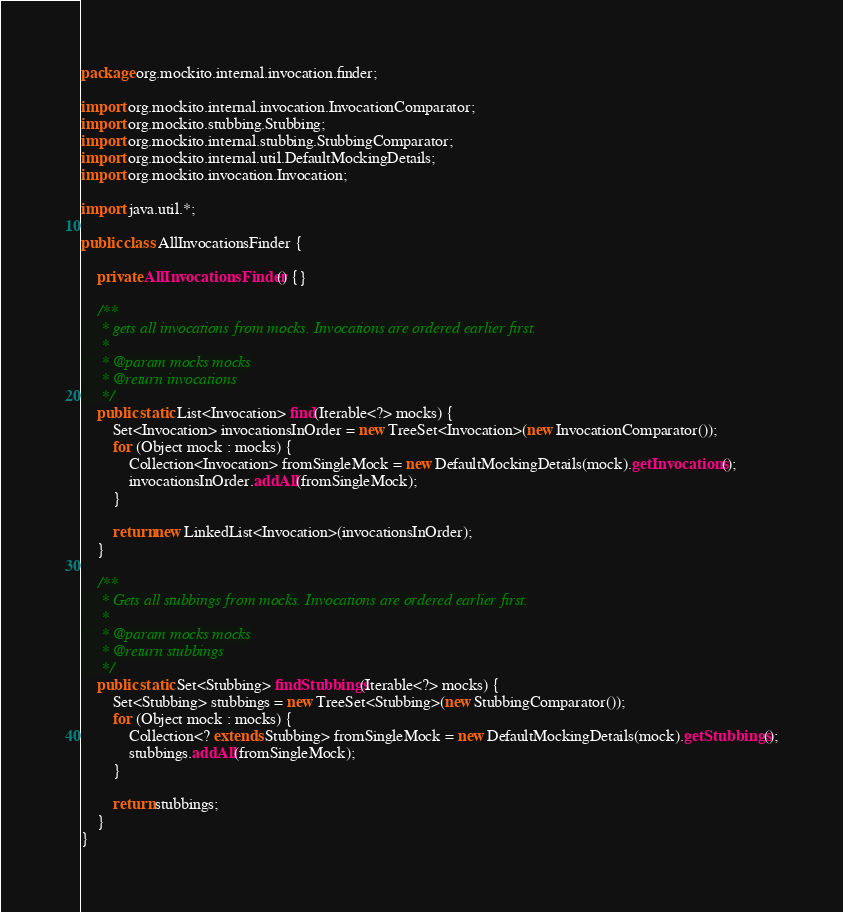<code> <loc_0><loc_0><loc_500><loc_500><_Java_>

package org.mockito.internal.invocation.finder;

import org.mockito.internal.invocation.InvocationComparator;
import org.mockito.stubbing.Stubbing;
import org.mockito.internal.stubbing.StubbingComparator;
import org.mockito.internal.util.DefaultMockingDetails;
import org.mockito.invocation.Invocation;

import java.util.*;

public class AllInvocationsFinder {

    private AllInvocationsFinder() {}

    /**
     * gets all invocations from mocks. Invocations are ordered earlier first.
     *
     * @param mocks mocks
     * @return invocations
     */
    public static List<Invocation> find(Iterable<?> mocks) {
        Set<Invocation> invocationsInOrder = new TreeSet<Invocation>(new InvocationComparator());
        for (Object mock : mocks) {
            Collection<Invocation> fromSingleMock = new DefaultMockingDetails(mock).getInvocations();
            invocationsInOrder.addAll(fromSingleMock);
        }

        return new LinkedList<Invocation>(invocationsInOrder);
    }

    /**
     * Gets all stubbings from mocks. Invocations are ordered earlier first.
     *
     * @param mocks mocks
     * @return stubbings
     */
    public static Set<Stubbing> findStubbings(Iterable<?> mocks) {
        Set<Stubbing> stubbings = new TreeSet<Stubbing>(new StubbingComparator());
        for (Object mock : mocks) {
            Collection<? extends Stubbing> fromSingleMock = new DefaultMockingDetails(mock).getStubbings();
            stubbings.addAll(fromSingleMock);
        }

        return stubbings;
    }
}
</code> 